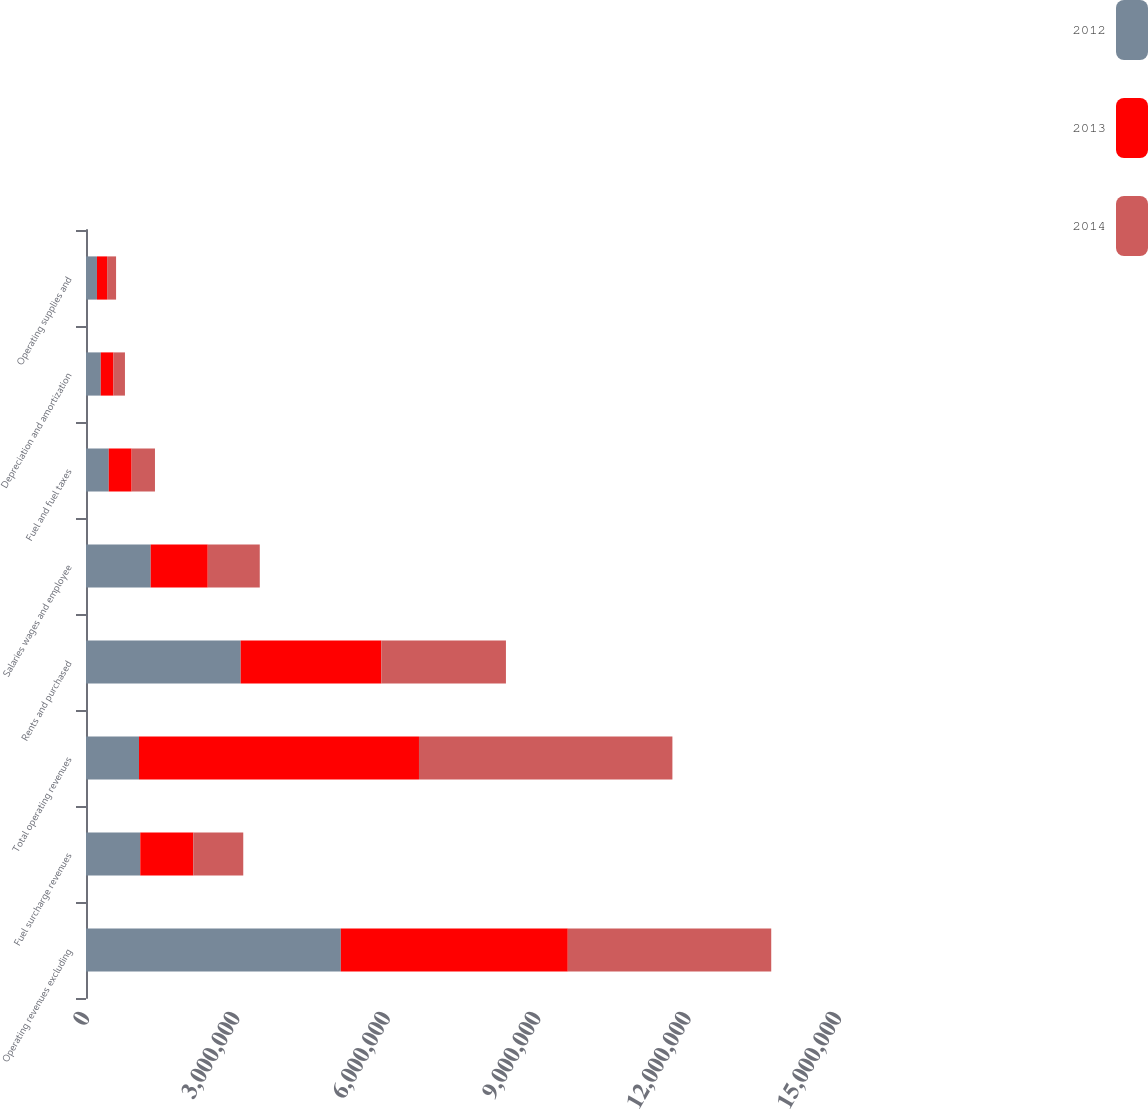Convert chart. <chart><loc_0><loc_0><loc_500><loc_500><stacked_bar_chart><ecel><fcel>Operating revenues excluding<fcel>Fuel surcharge revenues<fcel>Total operating revenues<fcel>Rents and purchased<fcel>Salaries wages and employee<fcel>Fuel and fuel taxes<fcel>Depreciation and amortization<fcel>Operating supplies and<nl><fcel>2012<fcel>5.08283e+06<fcel>1.08261e+06<fcel>1.05733e+06<fcel>3.08528e+06<fcel>1.2904e+06<fcel>453919<fcel>294496<fcel>218539<nl><fcel>2013<fcel>4.52724e+06<fcel>1.05733e+06<fcel>5.58457e+06<fcel>2.80557e+06<fcel>1.13821e+06<fcel>455926<fcel>253380<fcel>202700<nl><fcel>2014<fcel>4.05816e+06<fcel>996815<fcel>5.05498e+06<fcel>2.48564e+06<fcel>1.03753e+06<fcel>465874<fcel>229166<fcel>178610<nl></chart> 